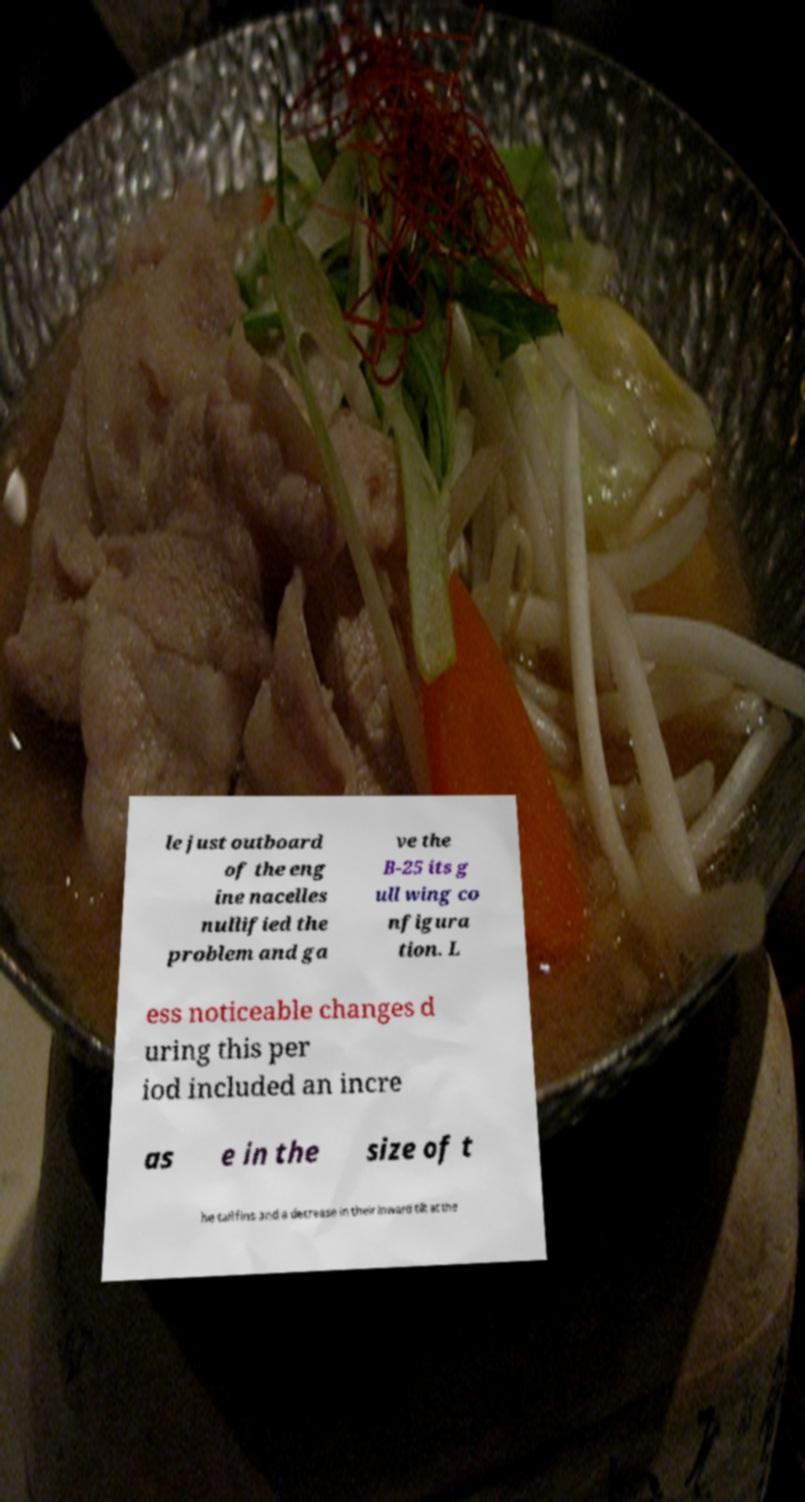Could you extract and type out the text from this image? le just outboard of the eng ine nacelles nullified the problem and ga ve the B-25 its g ull wing co nfigura tion. L ess noticeable changes d uring this per iod included an incre as e in the size of t he tail fins and a decrease in their inward tilt at the 